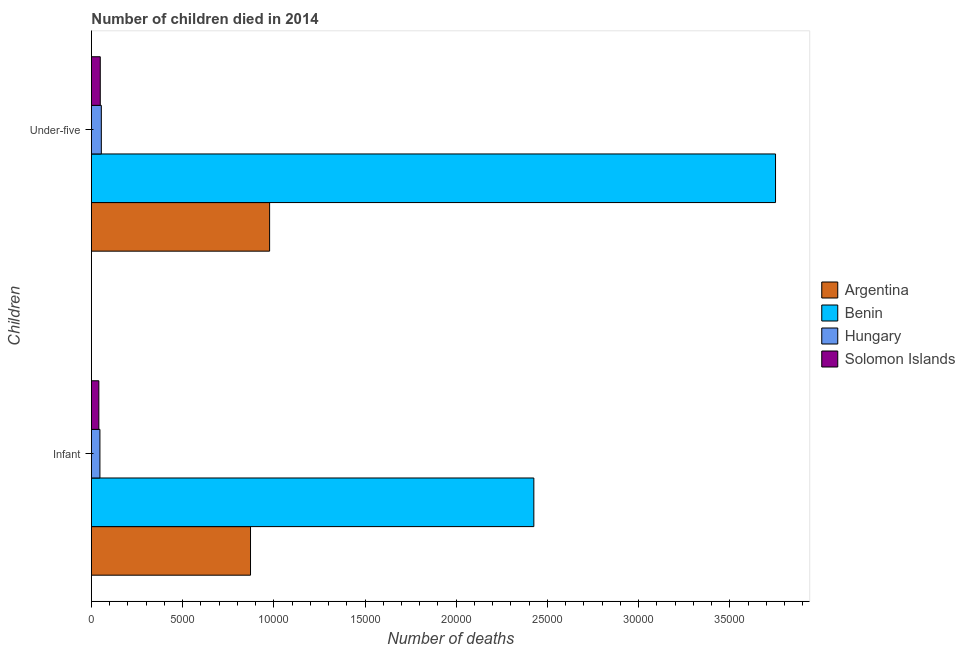Are the number of bars on each tick of the Y-axis equal?
Make the answer very short. Yes. How many bars are there on the 1st tick from the top?
Keep it short and to the point. 4. How many bars are there on the 1st tick from the bottom?
Give a very brief answer. 4. What is the label of the 1st group of bars from the top?
Keep it short and to the point. Under-five. What is the number of under-five deaths in Argentina?
Make the answer very short. 9770. Across all countries, what is the maximum number of infant deaths?
Your answer should be very brief. 2.43e+04. Across all countries, what is the minimum number of under-five deaths?
Offer a very short reply. 485. In which country was the number of infant deaths maximum?
Provide a succinct answer. Benin. In which country was the number of infant deaths minimum?
Ensure brevity in your answer.  Solomon Islands. What is the total number of infant deaths in the graph?
Your response must be concise. 3.39e+04. What is the difference between the number of infant deaths in Argentina and that in Benin?
Make the answer very short. -1.55e+04. What is the difference between the number of infant deaths in Solomon Islands and the number of under-five deaths in Benin?
Provide a succinct answer. -3.71e+04. What is the average number of infant deaths per country?
Offer a terse response. 8463.5. What is the difference between the number of under-five deaths and number of infant deaths in Argentina?
Ensure brevity in your answer.  1047. What is the ratio of the number of infant deaths in Benin to that in Argentina?
Your answer should be very brief. 2.78. What does the 2nd bar from the top in Infant represents?
Keep it short and to the point. Hungary. What does the 4th bar from the bottom in Infant represents?
Offer a terse response. Solomon Islands. Are all the bars in the graph horizontal?
Offer a very short reply. Yes. How many countries are there in the graph?
Provide a short and direct response. 4. Where does the legend appear in the graph?
Your answer should be very brief. Center right. How are the legend labels stacked?
Offer a very short reply. Vertical. What is the title of the graph?
Offer a terse response. Number of children died in 2014. What is the label or title of the X-axis?
Your answer should be very brief. Number of deaths. What is the label or title of the Y-axis?
Make the answer very short. Children. What is the Number of deaths of Argentina in Infant?
Give a very brief answer. 8723. What is the Number of deaths in Benin in Infant?
Ensure brevity in your answer.  2.43e+04. What is the Number of deaths of Hungary in Infant?
Offer a terse response. 466. What is the Number of deaths of Solomon Islands in Infant?
Provide a short and direct response. 407. What is the Number of deaths in Argentina in Under-five?
Ensure brevity in your answer.  9770. What is the Number of deaths in Benin in Under-five?
Your answer should be compact. 3.75e+04. What is the Number of deaths of Hungary in Under-five?
Make the answer very short. 543. What is the Number of deaths in Solomon Islands in Under-five?
Keep it short and to the point. 485. Across all Children, what is the maximum Number of deaths in Argentina?
Offer a terse response. 9770. Across all Children, what is the maximum Number of deaths of Benin?
Offer a terse response. 3.75e+04. Across all Children, what is the maximum Number of deaths in Hungary?
Your answer should be very brief. 543. Across all Children, what is the maximum Number of deaths of Solomon Islands?
Provide a succinct answer. 485. Across all Children, what is the minimum Number of deaths of Argentina?
Your response must be concise. 8723. Across all Children, what is the minimum Number of deaths in Benin?
Make the answer very short. 2.43e+04. Across all Children, what is the minimum Number of deaths in Hungary?
Offer a very short reply. 466. Across all Children, what is the minimum Number of deaths of Solomon Islands?
Your response must be concise. 407. What is the total Number of deaths of Argentina in the graph?
Offer a terse response. 1.85e+04. What is the total Number of deaths in Benin in the graph?
Offer a very short reply. 6.18e+04. What is the total Number of deaths in Hungary in the graph?
Keep it short and to the point. 1009. What is the total Number of deaths of Solomon Islands in the graph?
Offer a very short reply. 892. What is the difference between the Number of deaths in Argentina in Infant and that in Under-five?
Keep it short and to the point. -1047. What is the difference between the Number of deaths in Benin in Infant and that in Under-five?
Give a very brief answer. -1.33e+04. What is the difference between the Number of deaths of Hungary in Infant and that in Under-five?
Keep it short and to the point. -77. What is the difference between the Number of deaths of Solomon Islands in Infant and that in Under-five?
Keep it short and to the point. -78. What is the difference between the Number of deaths in Argentina in Infant and the Number of deaths in Benin in Under-five?
Offer a very short reply. -2.88e+04. What is the difference between the Number of deaths in Argentina in Infant and the Number of deaths in Hungary in Under-five?
Your response must be concise. 8180. What is the difference between the Number of deaths of Argentina in Infant and the Number of deaths of Solomon Islands in Under-five?
Your answer should be very brief. 8238. What is the difference between the Number of deaths of Benin in Infant and the Number of deaths of Hungary in Under-five?
Provide a short and direct response. 2.37e+04. What is the difference between the Number of deaths of Benin in Infant and the Number of deaths of Solomon Islands in Under-five?
Your answer should be compact. 2.38e+04. What is the average Number of deaths in Argentina per Children?
Your response must be concise. 9246.5. What is the average Number of deaths in Benin per Children?
Keep it short and to the point. 3.09e+04. What is the average Number of deaths in Hungary per Children?
Your answer should be very brief. 504.5. What is the average Number of deaths of Solomon Islands per Children?
Provide a succinct answer. 446. What is the difference between the Number of deaths in Argentina and Number of deaths in Benin in Infant?
Provide a succinct answer. -1.55e+04. What is the difference between the Number of deaths of Argentina and Number of deaths of Hungary in Infant?
Offer a terse response. 8257. What is the difference between the Number of deaths in Argentina and Number of deaths in Solomon Islands in Infant?
Give a very brief answer. 8316. What is the difference between the Number of deaths in Benin and Number of deaths in Hungary in Infant?
Make the answer very short. 2.38e+04. What is the difference between the Number of deaths of Benin and Number of deaths of Solomon Islands in Infant?
Make the answer very short. 2.39e+04. What is the difference between the Number of deaths in Hungary and Number of deaths in Solomon Islands in Infant?
Provide a short and direct response. 59. What is the difference between the Number of deaths in Argentina and Number of deaths in Benin in Under-five?
Your answer should be compact. -2.77e+04. What is the difference between the Number of deaths in Argentina and Number of deaths in Hungary in Under-five?
Keep it short and to the point. 9227. What is the difference between the Number of deaths in Argentina and Number of deaths in Solomon Islands in Under-five?
Offer a very short reply. 9285. What is the difference between the Number of deaths of Benin and Number of deaths of Hungary in Under-five?
Offer a terse response. 3.70e+04. What is the difference between the Number of deaths of Benin and Number of deaths of Solomon Islands in Under-five?
Give a very brief answer. 3.70e+04. What is the difference between the Number of deaths in Hungary and Number of deaths in Solomon Islands in Under-five?
Provide a succinct answer. 58. What is the ratio of the Number of deaths of Argentina in Infant to that in Under-five?
Keep it short and to the point. 0.89. What is the ratio of the Number of deaths in Benin in Infant to that in Under-five?
Offer a very short reply. 0.65. What is the ratio of the Number of deaths in Hungary in Infant to that in Under-five?
Your response must be concise. 0.86. What is the ratio of the Number of deaths in Solomon Islands in Infant to that in Under-five?
Your answer should be compact. 0.84. What is the difference between the highest and the second highest Number of deaths of Argentina?
Provide a short and direct response. 1047. What is the difference between the highest and the second highest Number of deaths in Benin?
Your answer should be compact. 1.33e+04. What is the difference between the highest and the second highest Number of deaths in Solomon Islands?
Your answer should be compact. 78. What is the difference between the highest and the lowest Number of deaths in Argentina?
Your response must be concise. 1047. What is the difference between the highest and the lowest Number of deaths of Benin?
Give a very brief answer. 1.33e+04. What is the difference between the highest and the lowest Number of deaths of Solomon Islands?
Keep it short and to the point. 78. 